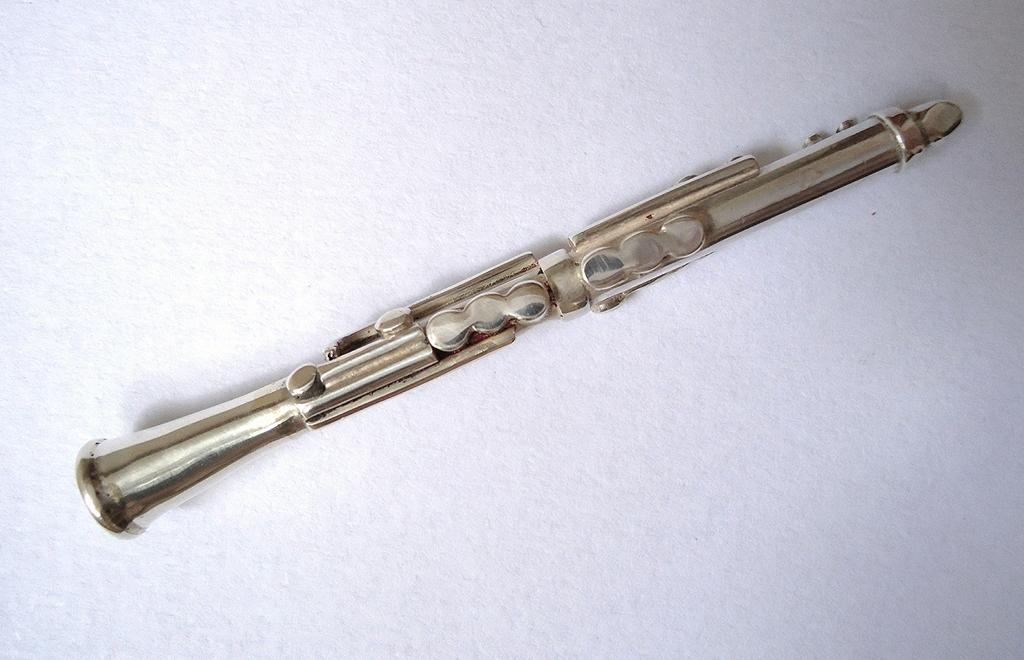What type of object is located in the center of the image? There is a metal object in the image, and it is placed in the center. What can be inferred about the object's positioning in the image? The metal object is on a surface in the image. What type of leather material can be seen on the metal object in the image? There is no leather material present on the metal object in the image. What type of wire is connected to the metal object in the image? There is no wire connected to the metal object in the image. 